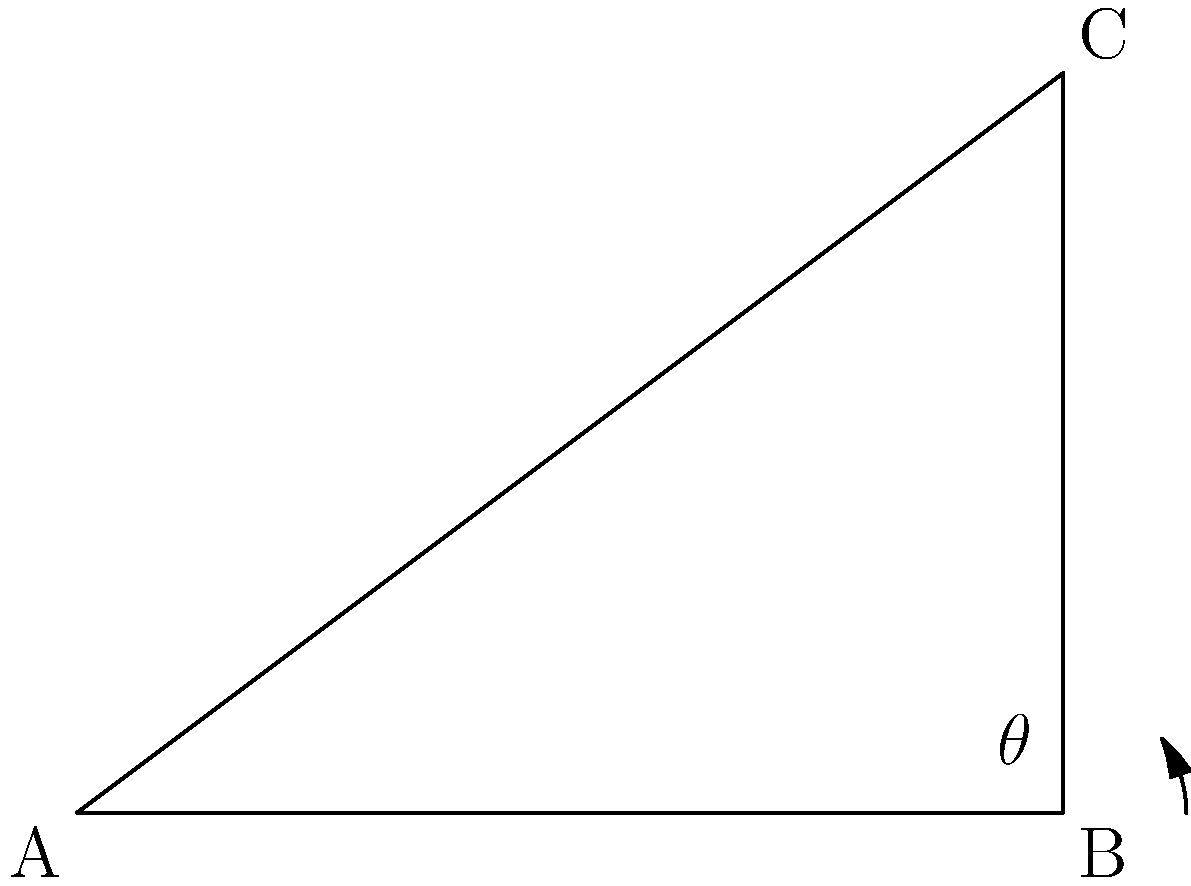As you approach a highway interchange, you hear a truck driver on the radio mention a sharp turn ahead. Looking at your GPS, you see the interchange forms a right-angled triangle. If the straight portion before the turn is 4 miles long and the straight portion after the turn is 3 miles long, what is the angle of the turn in degrees? Let's approach this step-by-step:

1) The interchange forms a right-angled triangle, with the turn angle being one of the acute angles.

2) We know two sides of this triangle:
   - The side before the turn (adjacent to our angle) is 4 miles
   - The side after the turn (opposite to our angle) is 3 miles

3) To find the angle, we can use the trigonometric function tangent (tan):

   $\tan \theta = \frac{\text{opposite}}{\text{adjacent}} = \frac{3}{4}$

4) To get the angle, we need to take the inverse tangent (arctan or $\tan^{-1}$):

   $\theta = \tan^{-1}(\frac{3}{4})$

5) Using a calculator or trigonometric tables:

   $\theta \approx 36.87°$

6) Rounding to the nearest degree:

   $\theta \approx 37°$

This means the turn angle on the highway interchange is approximately 37 degrees.
Answer: $37°$ 